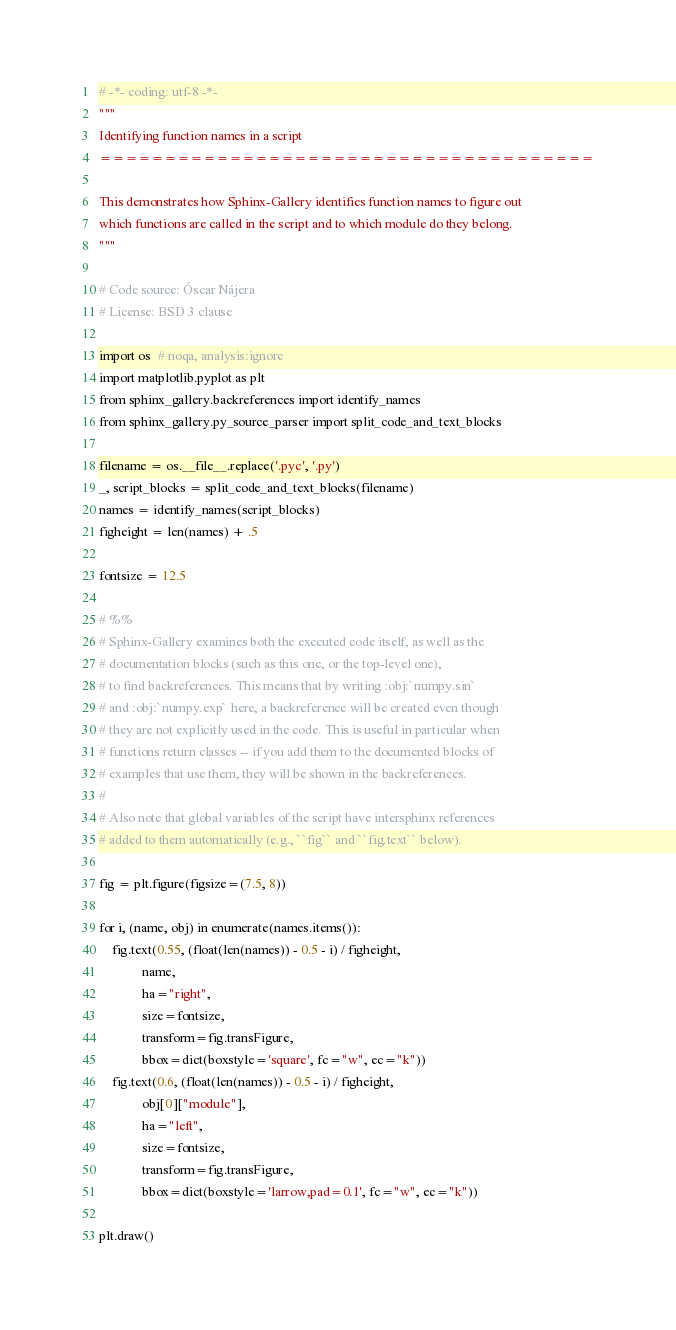<code> <loc_0><loc_0><loc_500><loc_500><_Python_># -*- coding: utf-8 -*-
"""
Identifying function names in a script
======================================

This demonstrates how Sphinx-Gallery identifies function names to figure out
which functions are called in the script and to which module do they belong.
"""

# Code source: Óscar Nájera
# License: BSD 3 clause

import os  # noqa, analysis:ignore
import matplotlib.pyplot as plt
from sphinx_gallery.backreferences import identify_names
from sphinx_gallery.py_source_parser import split_code_and_text_blocks

filename = os.__file__.replace('.pyc', '.py')
_, script_blocks = split_code_and_text_blocks(filename)
names = identify_names(script_blocks)
figheight = len(names) + .5

fontsize = 12.5

# %%
# Sphinx-Gallery examines both the executed code itself, as well as the
# documentation blocks (such as this one, or the top-level one),
# to find backreferences. This means that by writing :obj:`numpy.sin`
# and :obj:`numpy.exp` here, a backreference will be created even though
# they are not explicitly used in the code. This is useful in particular when
# functions return classes -- if you add them to the documented blocks of
# examples that use them, they will be shown in the backreferences.
#
# Also note that global variables of the script have intersphinx references
# added to them automatically (e.g., ``fig`` and ``fig.text`` below).

fig = plt.figure(figsize=(7.5, 8))

for i, (name, obj) in enumerate(names.items()):
    fig.text(0.55, (float(len(names)) - 0.5 - i) / figheight,
             name,
             ha="right",
             size=fontsize,
             transform=fig.transFigure,
             bbox=dict(boxstyle='square', fc="w", ec="k"))
    fig.text(0.6, (float(len(names)) - 0.5 - i) / figheight,
             obj[0]["module"],
             ha="left",
             size=fontsize,
             transform=fig.transFigure,
             bbox=dict(boxstyle='larrow,pad=0.1', fc="w", ec="k"))

plt.draw()
</code> 